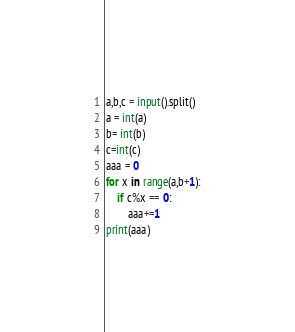<code> <loc_0><loc_0><loc_500><loc_500><_Python_>a,b,c = input().split()
a = int(a)
b= int(b)
c=int(c)
aaa = 0
for x in range(a,b+1):
    if c%x == 0:
        aaa+=1
print(aaa)



</code> 